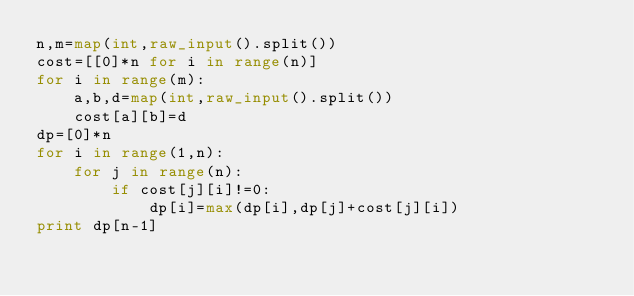<code> <loc_0><loc_0><loc_500><loc_500><_Python_>n,m=map(int,raw_input().split())
cost=[[0]*n for i in range(n)]
for i in range(m):
    a,b,d=map(int,raw_input().split())
    cost[a][b]=d
dp=[0]*n
for i in range(1,n):
    for j in range(n):
        if cost[j][i]!=0:
            dp[i]=max(dp[i],dp[j]+cost[j][i])
print dp[n-1]</code> 